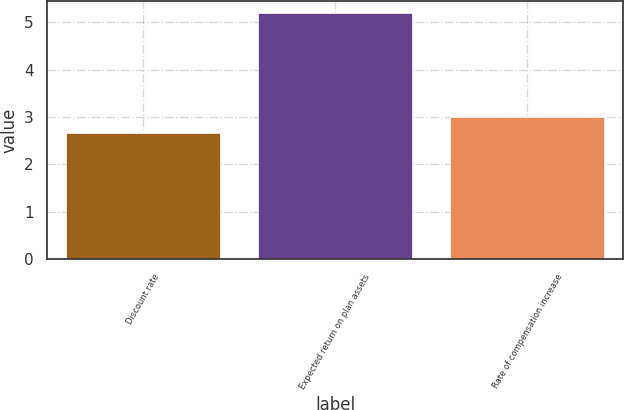Convert chart. <chart><loc_0><loc_0><loc_500><loc_500><bar_chart><fcel>Discount rate<fcel>Expected return on plan assets<fcel>Rate of compensation increase<nl><fcel>2.66<fcel>5.19<fcel>3<nl></chart> 